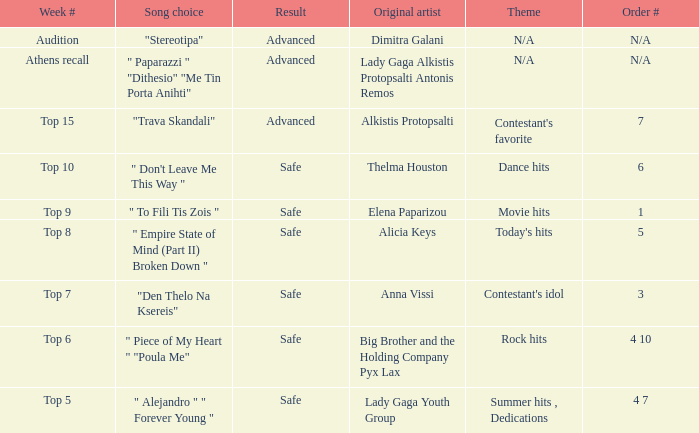What are all the order #s from the week "top 6"? 4 10. Parse the full table. {'header': ['Week #', 'Song choice', 'Result', 'Original artist', 'Theme', 'Order #'], 'rows': [['Audition', '"Stereotipa"', 'Advanced', 'Dimitra Galani', 'N/A', 'N/A'], ['Athens recall', '" Paparazzi " "Dithesio" "Me Tin Porta Anihti"', 'Advanced', 'Lady Gaga Alkistis Protopsalti Antonis Remos', 'N/A', 'N/A'], ['Top 15', '"Trava Skandali"', 'Advanced', 'Alkistis Protopsalti', "Contestant's favorite", '7'], ['Top 10', '" Don\'t Leave Me This Way "', 'Safe', 'Thelma Houston', 'Dance hits', '6'], ['Top 9', '" To Fili Tis Zois "', 'Safe', 'Elena Paparizou', 'Movie hits', '1'], ['Top 8', '" Empire State of Mind (Part II) Broken Down "', 'Safe', 'Alicia Keys', "Today's hits", '5'], ['Top 7', '"Den Thelo Na Ksereis"', 'Safe', 'Anna Vissi', "Contestant's idol", '3'], ['Top 6', '" Piece of My Heart " "Poula Me"', 'Safe', 'Big Brother and the Holding Company Pyx Lax', 'Rock hits', '4 10'], ['Top 5', '" Alejandro " " Forever Young "', 'Safe', 'Lady Gaga Youth Group', 'Summer hits , Dedications', '4 7']]} 